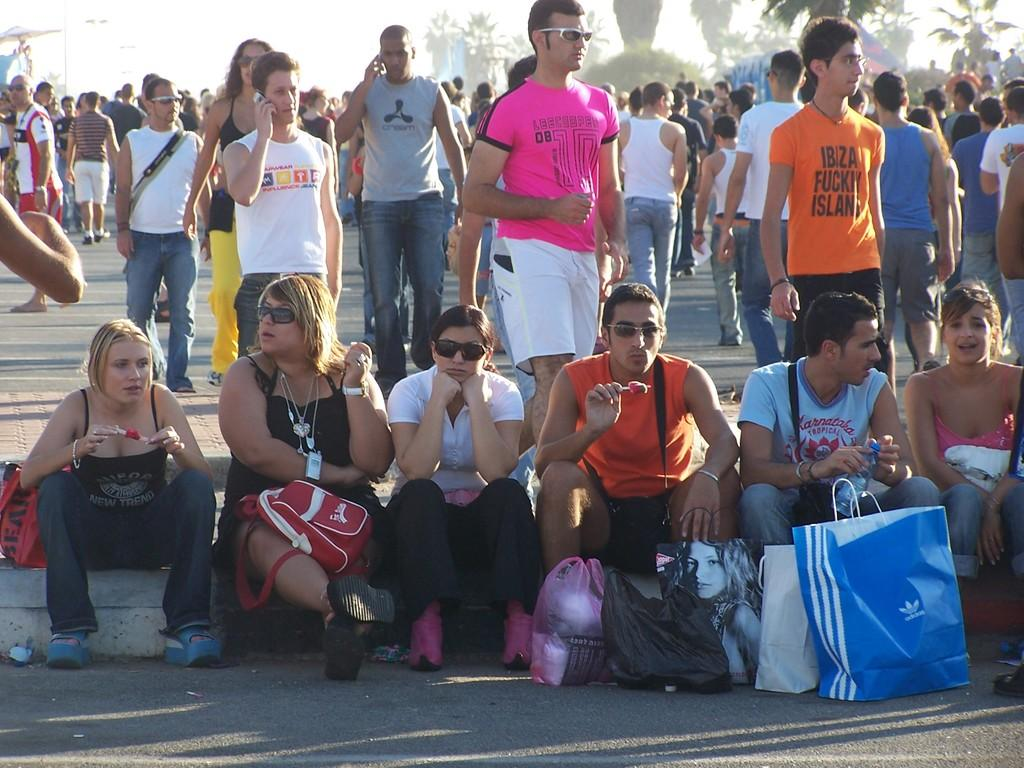<image>
Summarize the visual content of the image. a few people outside with one wearing a pink shirt with 8 on it 